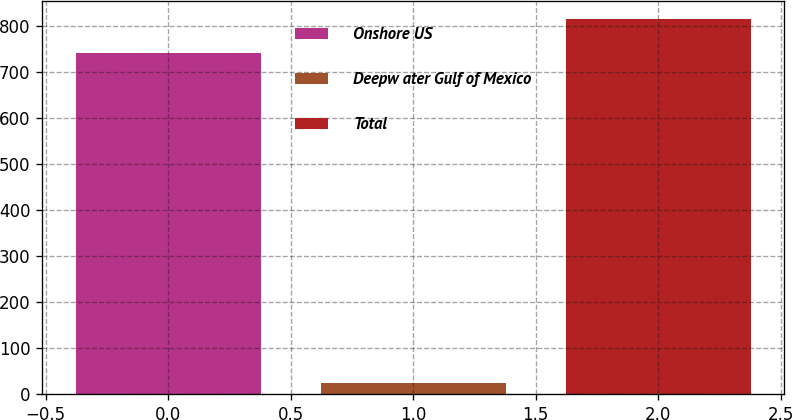<chart> <loc_0><loc_0><loc_500><loc_500><bar_chart><fcel>Onshore US<fcel>Deepw ater Gulf of Mexico<fcel>Total<nl><fcel>740<fcel>23<fcel>814<nl></chart> 